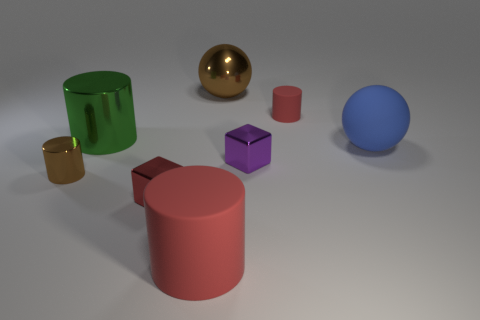There is a sphere that is in front of the red thing behind the sphere that is in front of the big green metal cylinder; what size is it? The sphere in question is medium-sized, appearing to be approximately the same size as the purple cube nearby. Its placement in front of the red cylinder adds depth to the composition. 